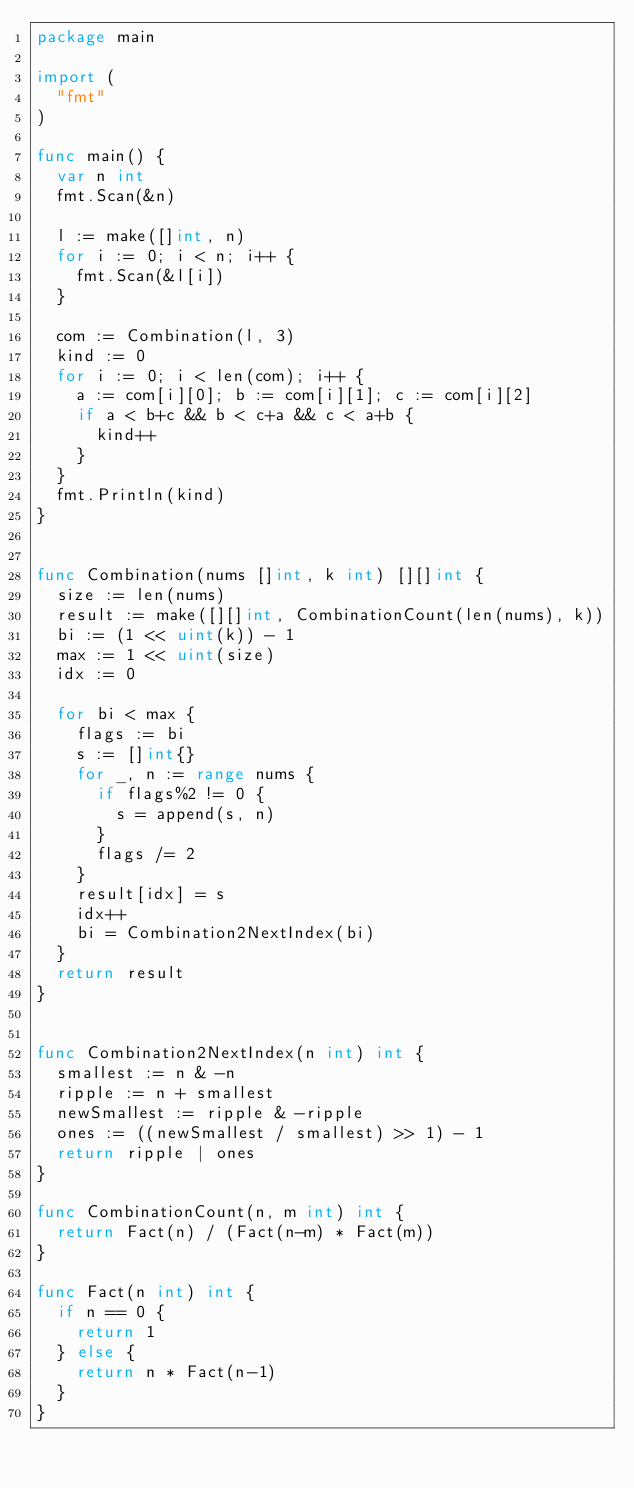Convert code to text. <code><loc_0><loc_0><loc_500><loc_500><_Go_>package main

import (
	"fmt"
)

func main() {
	var n int
	fmt.Scan(&n)

	l := make([]int, n)
	for i := 0; i < n; i++ {
		fmt.Scan(&l[i])
	}

	com := Combination(l, 3)
	kind := 0
	for i := 0; i < len(com); i++ {
		a := com[i][0]; b := com[i][1]; c := com[i][2]
		if a < b+c && b < c+a && c < a+b {
			kind++
		}
	}
	fmt.Println(kind)
}


func Combination(nums []int, k int) [][]int {
	size := len(nums)
	result := make([][]int, CombinationCount(len(nums), k))
	bi := (1 << uint(k)) - 1
	max := 1 << uint(size)
	idx := 0

	for bi < max {
		flags := bi
		s := []int{}
		for _, n := range nums {
			if flags%2 != 0 {
				s = append(s, n)
			}
			flags /= 2
		}
		result[idx] = s
		idx++
		bi = Combination2NextIndex(bi)
	}
	return result
}


func Combination2NextIndex(n int) int {
	smallest := n & -n
	ripple := n + smallest
	newSmallest := ripple & -ripple
	ones := ((newSmallest / smallest) >> 1) - 1
	return ripple | ones
}

func CombinationCount(n, m int) int {
	return Fact(n) / (Fact(n-m) * Fact(m))
}

func Fact(n int) int {
	if n == 0 {
		return 1
	} else {
		return n * Fact(n-1)
	}
}</code> 